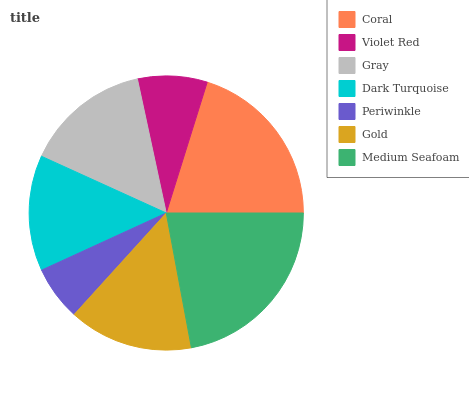Is Periwinkle the minimum?
Answer yes or no. Yes. Is Medium Seafoam the maximum?
Answer yes or no. Yes. Is Violet Red the minimum?
Answer yes or no. No. Is Violet Red the maximum?
Answer yes or no. No. Is Coral greater than Violet Red?
Answer yes or no. Yes. Is Violet Red less than Coral?
Answer yes or no. Yes. Is Violet Red greater than Coral?
Answer yes or no. No. Is Coral less than Violet Red?
Answer yes or no. No. Is Gold the high median?
Answer yes or no. Yes. Is Gold the low median?
Answer yes or no. Yes. Is Dark Turquoise the high median?
Answer yes or no. No. Is Gray the low median?
Answer yes or no. No. 